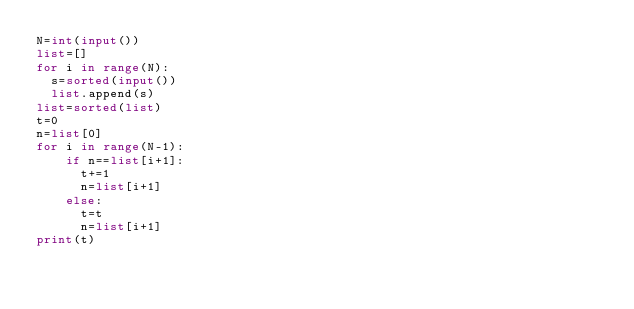Convert code to text. <code><loc_0><loc_0><loc_500><loc_500><_Python_>N=int(input())
list=[]
for i in range(N):
  s=sorted(input())
  list.append(s)
list=sorted(list)
t=0
n=list[0]
for i in range(N-1):
    if n==list[i+1]:
      t+=1
      n=list[i+1]
    else:
      t=t
      n=list[i+1]
print(t)</code> 